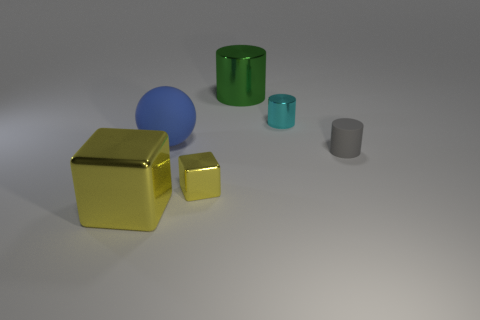The small cylinder that is in front of the rubber object that is left of the cyan metallic object is made of what material?
Provide a short and direct response. Rubber. Are there any small gray cylinders right of the ball?
Your answer should be compact. Yes. Is the size of the green cylinder the same as the cyan thing that is left of the gray object?
Provide a short and direct response. No. There is a green shiny object that is the same shape as the small gray matte object; what size is it?
Your answer should be very brief. Large. Is there anything else that is made of the same material as the gray cylinder?
Make the answer very short. Yes. There is a metallic cylinder on the right side of the green metallic object; does it have the same size as the rubber thing that is on the left side of the gray rubber cylinder?
Your response must be concise. No. How many tiny objects are yellow objects or cyan metallic cubes?
Ensure brevity in your answer.  1. What number of large things are both in front of the small rubber object and on the right side of the big rubber object?
Offer a terse response. 0. Does the blue sphere have the same material as the small cylinder that is in front of the big rubber ball?
Your response must be concise. Yes. How many green things are either big cylinders or large metal spheres?
Keep it short and to the point. 1. 